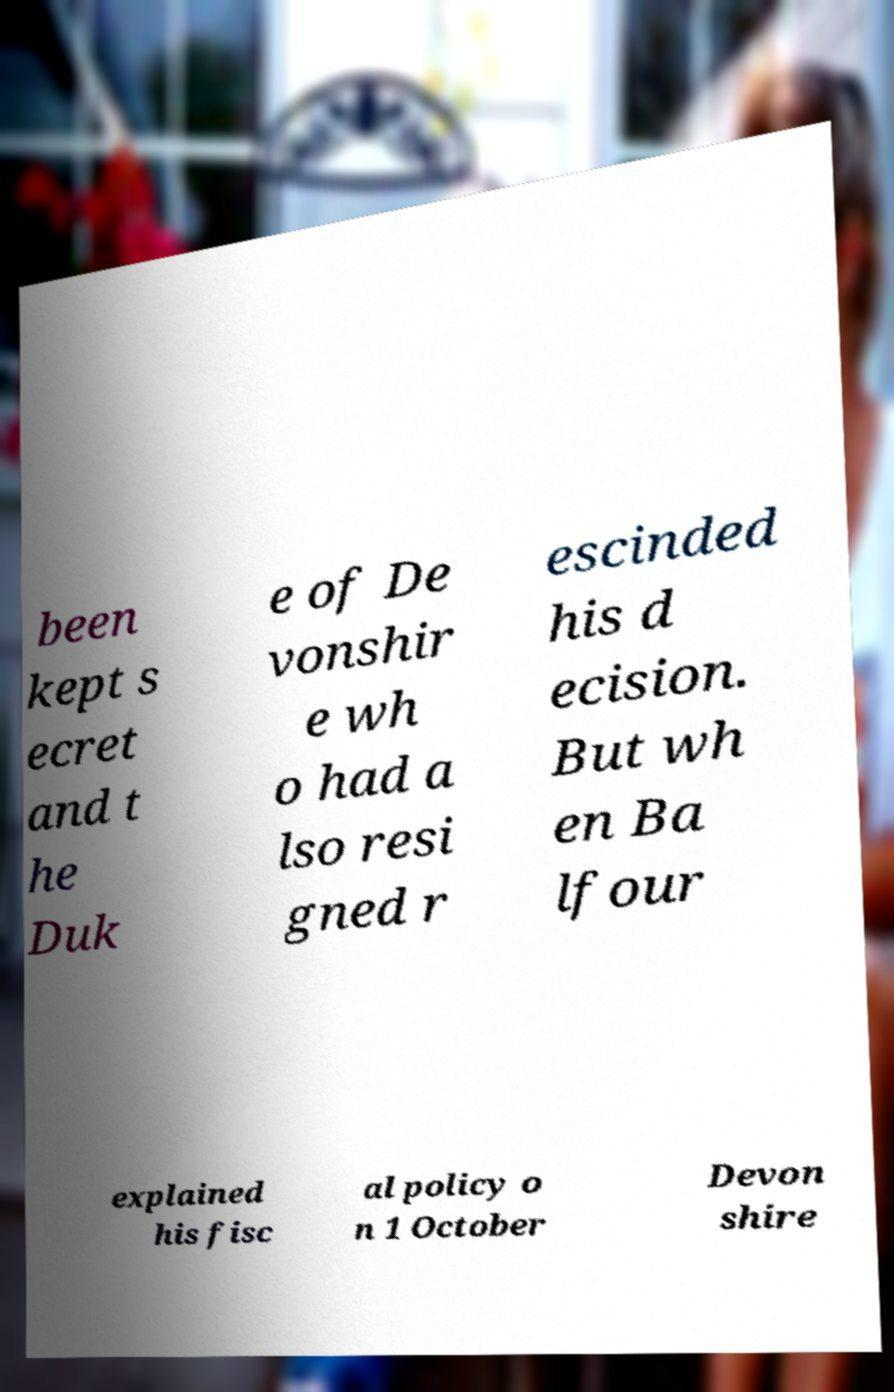For documentation purposes, I need the text within this image transcribed. Could you provide that? been kept s ecret and t he Duk e of De vonshir e wh o had a lso resi gned r escinded his d ecision. But wh en Ba lfour explained his fisc al policy o n 1 October Devon shire 